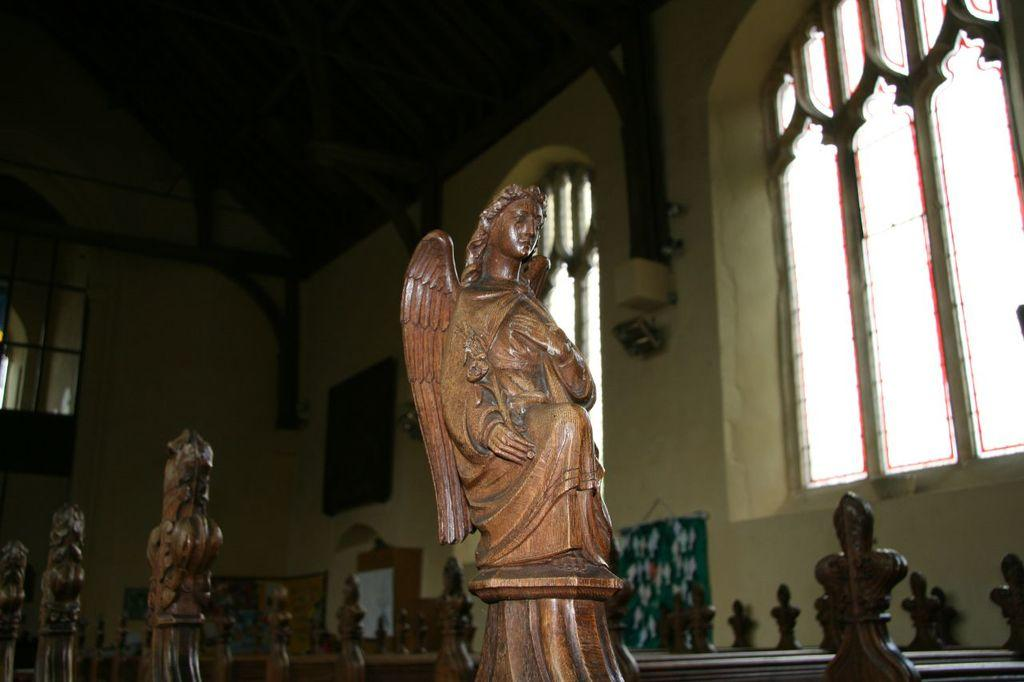What type of structures can be seen in the image? There are statues, walls, windows, and a roof visible in the image. Can you describe the statues in the image? Unfortunately, the facts provided do not give any details about the statues, so we cannot describe them. What architectural features are present in the image? The image features walls, windows, and a roof. How many dimes are placed on the windowsill in the image? There is no mention of dimes in the image, so we cannot determine how many are present. What type of pies are being served in the image? There is no mention of pies in the image, so we cannot determine what type is being served. 